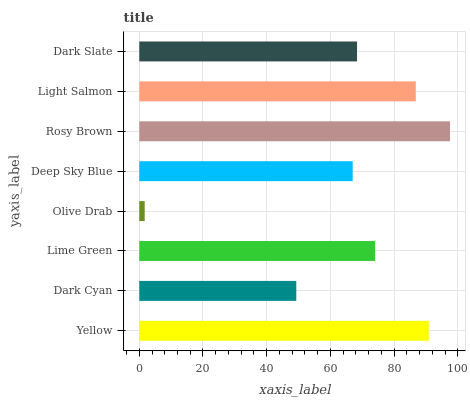Is Olive Drab the minimum?
Answer yes or no. Yes. Is Rosy Brown the maximum?
Answer yes or no. Yes. Is Dark Cyan the minimum?
Answer yes or no. No. Is Dark Cyan the maximum?
Answer yes or no. No. Is Yellow greater than Dark Cyan?
Answer yes or no. Yes. Is Dark Cyan less than Yellow?
Answer yes or no. Yes. Is Dark Cyan greater than Yellow?
Answer yes or no. No. Is Yellow less than Dark Cyan?
Answer yes or no. No. Is Lime Green the high median?
Answer yes or no. Yes. Is Dark Slate the low median?
Answer yes or no. Yes. Is Light Salmon the high median?
Answer yes or no. No. Is Dark Cyan the low median?
Answer yes or no. No. 